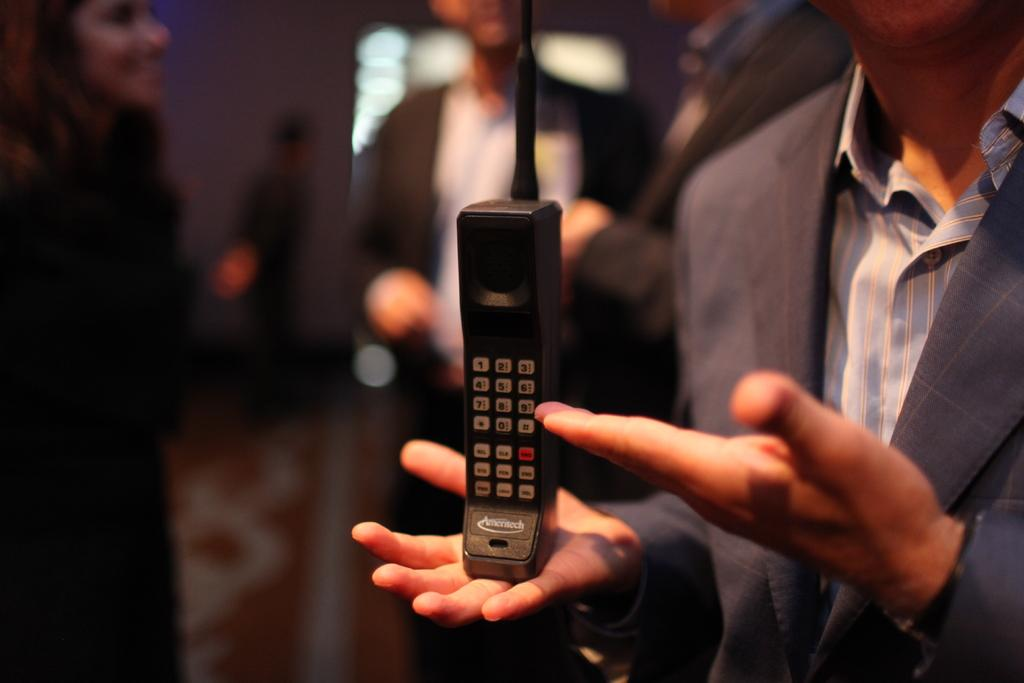How many people are present in the image? There are many people in the image. What object can be seen in the image besides the people? There is a telephone in the image. What type of toothpaste is being used on the sidewalk in the image? There is no toothpaste or sidewalk present in the image. How does the heat affect the people in the image? The provided facts do not mention any heat or temperature, so we cannot determine how it affects the people in the image. 